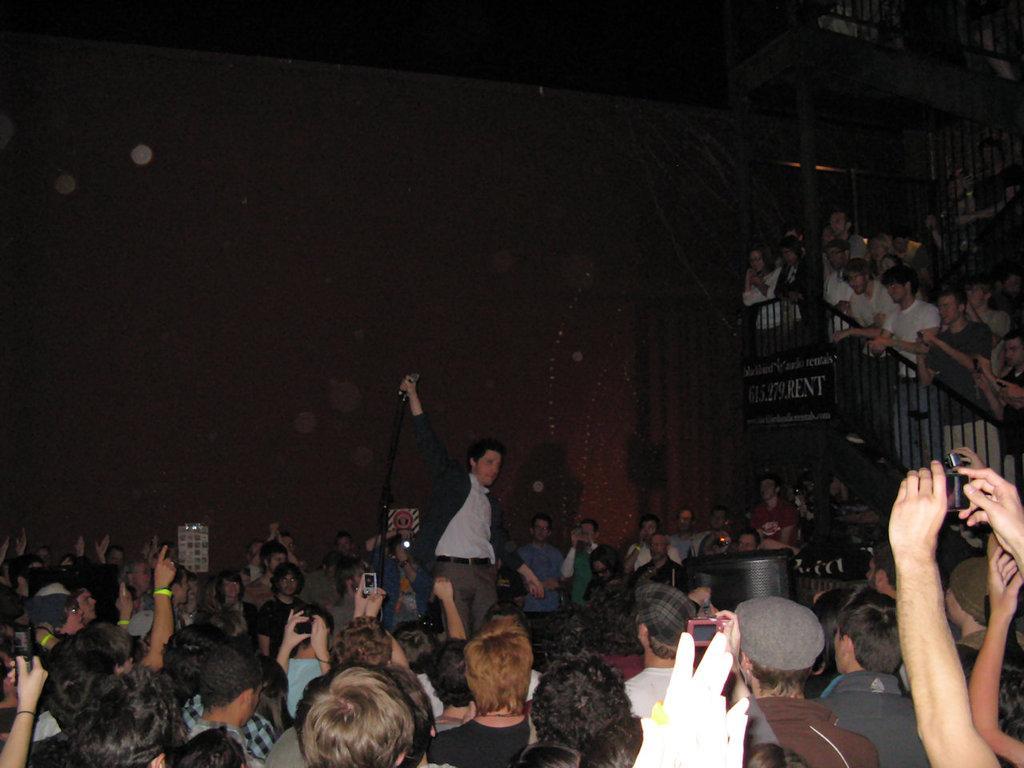Could you give a brief overview of what you see in this image? In this picture I can observe some people sitting in the chairs. On the right side there are stairs and a black color railing. I can observe men and women in this picture. There is a person standing in the middle of the image. In the background there is a wall. 